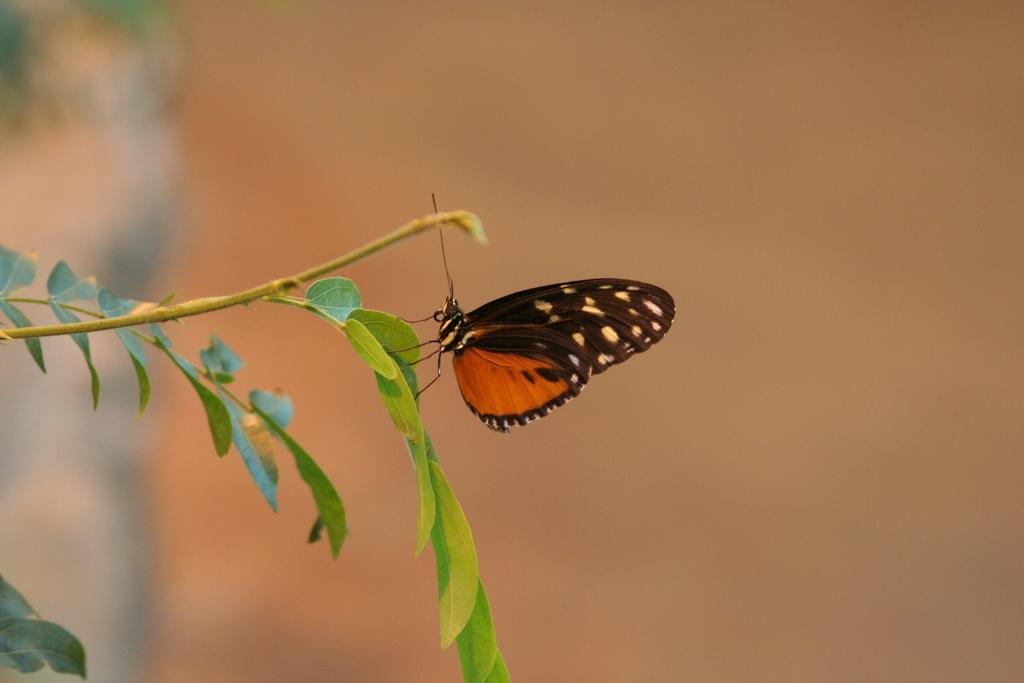What is the main subject of the image? There is a butterfly on green leaves in the image. What type of vegetation is present in the image? There are leaves and a stem visible in the image. How would you describe the background of the image? The background of the image is blurry. What type of collar can be seen on the fruit in the image? There is no fruit or collar present in the image; it features a butterfly on green leaves. 